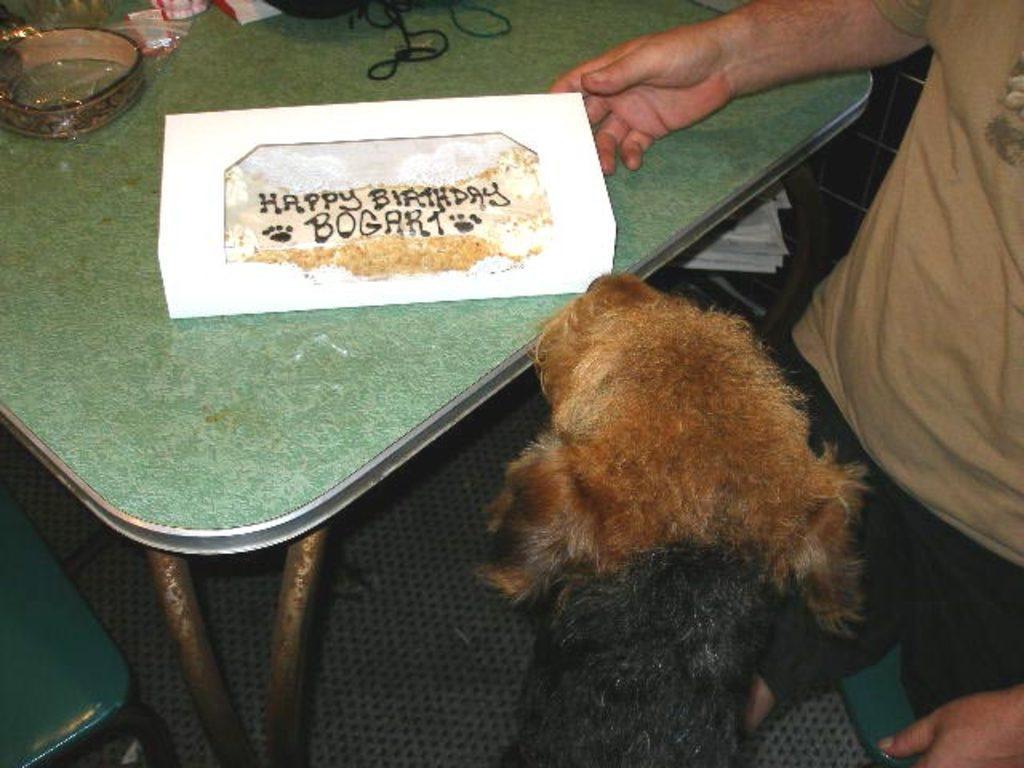Describe this image in one or two sentences. In this image I can see a person and a brown and black colour animal. I can also see green colour table and on it I can see white colour thing. I can also see few other stuffs over here and on this I can see something is written. 